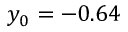<formula> <loc_0><loc_0><loc_500><loc_500>y _ { 0 } = - 0 . 6 4</formula> 